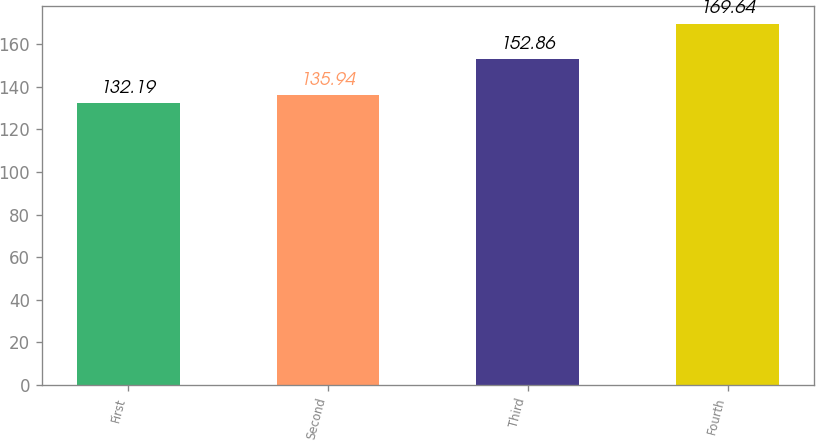<chart> <loc_0><loc_0><loc_500><loc_500><bar_chart><fcel>First<fcel>Second<fcel>Third<fcel>Fourth<nl><fcel>132.19<fcel>135.94<fcel>152.86<fcel>169.64<nl></chart> 